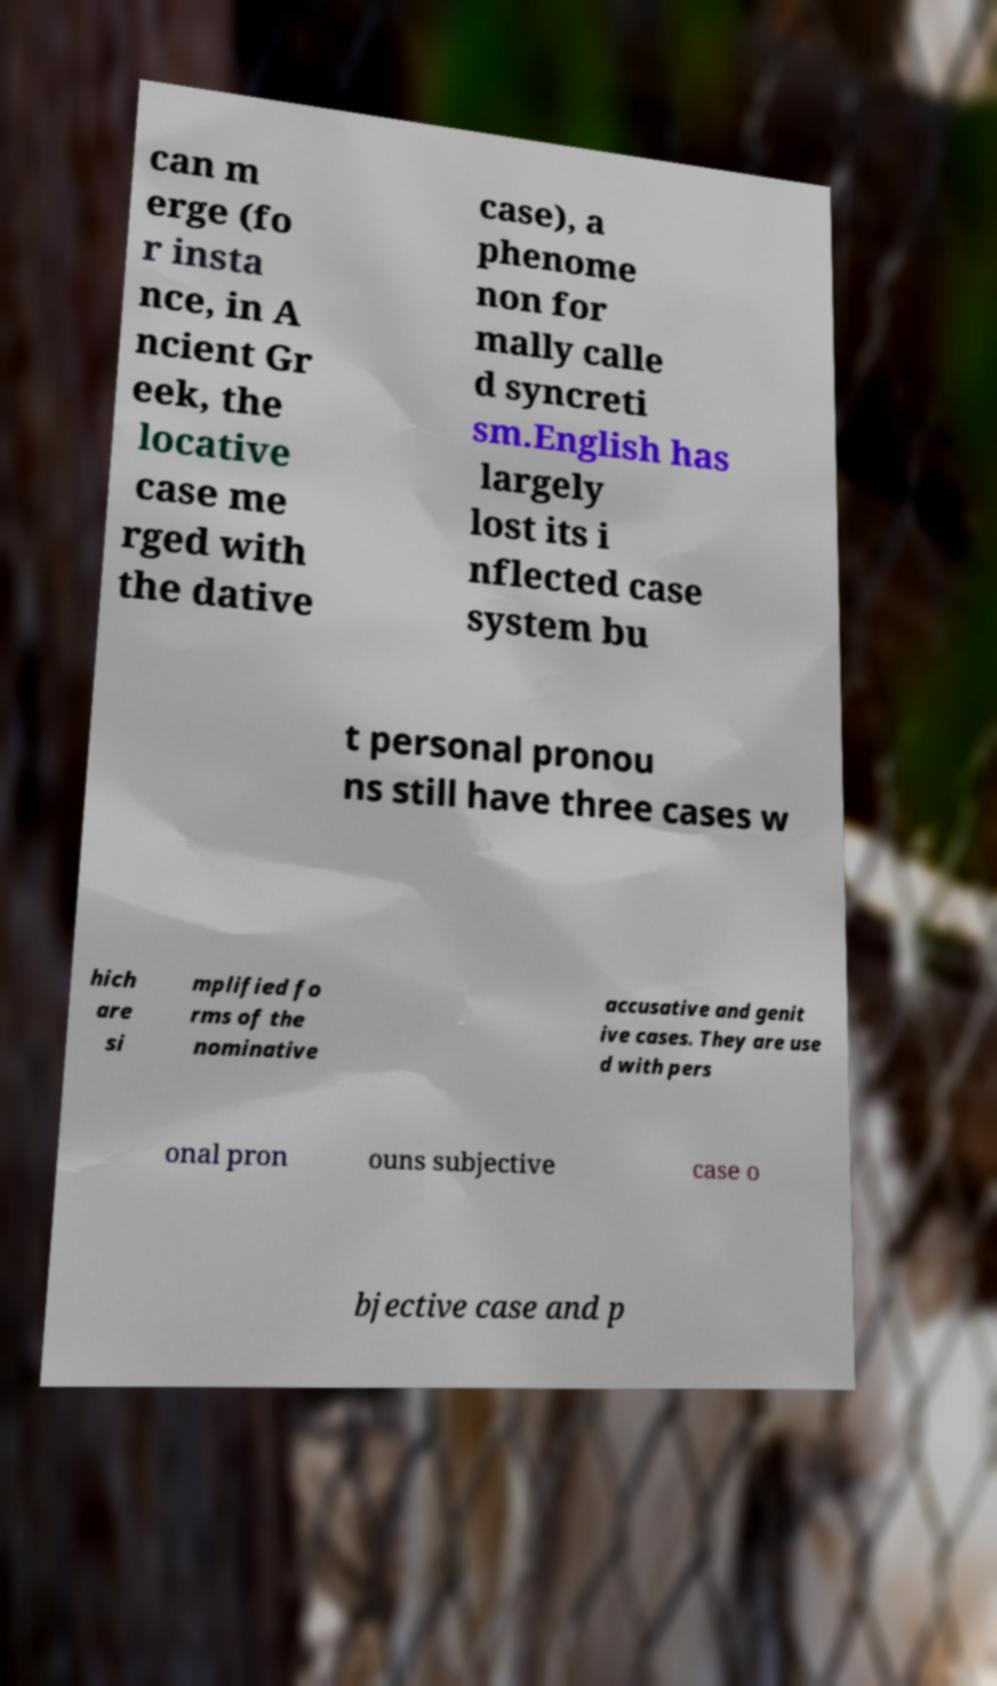Please identify and transcribe the text found in this image. can m erge (fo r insta nce, in A ncient Gr eek, the locative case me rged with the dative case), a phenome non for mally calle d syncreti sm.English has largely lost its i nflected case system bu t personal pronou ns still have three cases w hich are si mplified fo rms of the nominative accusative and genit ive cases. They are use d with pers onal pron ouns subjective case o bjective case and p 